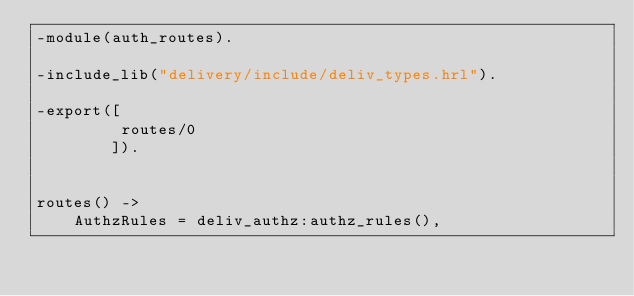<code> <loc_0><loc_0><loc_500><loc_500><_Erlang_>-module(auth_routes).

-include_lib("delivery/include/deliv_types.hrl").

-export([
         routes/0
        ]).


routes() ->
    AuthzRules = deliv_authz:authz_rules(),</code> 